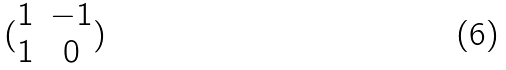Convert formula to latex. <formula><loc_0><loc_0><loc_500><loc_500>( \begin{matrix} 1 & - 1 \\ 1 & 0 \end{matrix} )</formula> 